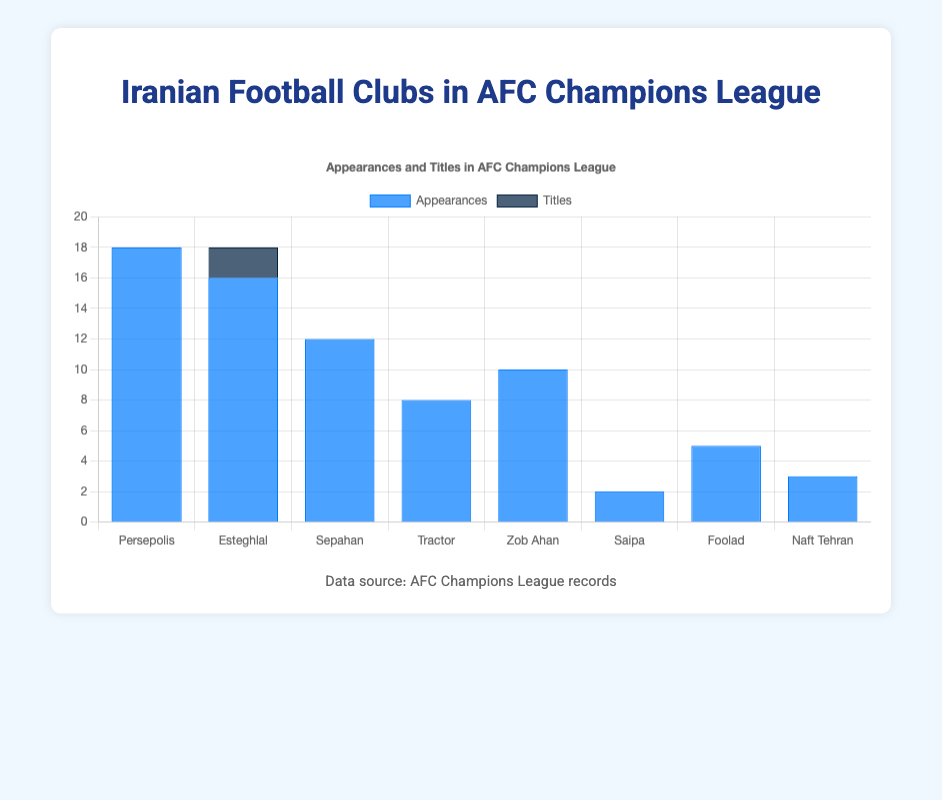Which club has the highest number of appearances in the AFC Champions League? By analyzing the heights of the blue bars representing appearances, Persepolis has the highest bar.
Answer: Persepolis How many titles do Iranian clubs have in total? Adding up the dark blue bars for titles, we get Esteghlal with 2 titles.
Answer: 2 Which club has more appearances, Zob Ahan or Tractor? Comparing the heights of the blue bars for Zob Ahan and Tractor, Zob Ahan's bar is higher.
Answer: Zob Ahan What is the total number of appearances by the top three clubs? Adding the blue bars for Persepolis (18), Esteghlal (16), and Sepahan (12), the total is 18 + 16 + 12 = 46.
Answer: 46 Which club has reached the runner-up position twice? Observing the data, Persepolis is the only club with a runner-up position twice.
Answer: Persepolis What is the average number of appearances by Iranian clubs in the chart? Summing the number of appearances (18 + 16 + 12 + 8 + 10 + 2 + 5 + 3 = 74) and then dividing by the number of clubs (8), gives 74/8 = 9.25.
Answer: 9.25 Which clubs have never won a title? Examining all the dark blue bars except Esteghlal, Persepolis, Sepahan, Tractor, Zob Ahan, Saipa, Foolad, and Naft Tehran all have no titles.
Answer: Persepolis, Sepahan, Tractor, Zob Ahan, Saipa, Foolad, Naft Tehran How many clubs have had runner-up finishes in the AFC Champions League? Counting all clubs with non-zero runner-up bar values: Persepolis, Sepahan, and Zob Ahan, we get 3 clubs.
Answer: 3 What is the difference in the number of appearances between the club with the most appearances and the one with the fewest? Persepolis has 18 appearances and Saipa has 2 appearances, so the difference is 18 - 2 = 16.
Answer: 16 Do more clubs have appearances in the single digits or double digits? Counting clubs with single-digit appearances (Tractor, Saipa, Foolad, Naft Tehran = 4) and those with double-digit appearances (Persepolis, Esteghlal, Sepahan, Zob Ahan = 4), the numbers are equal.
Answer: Equal 